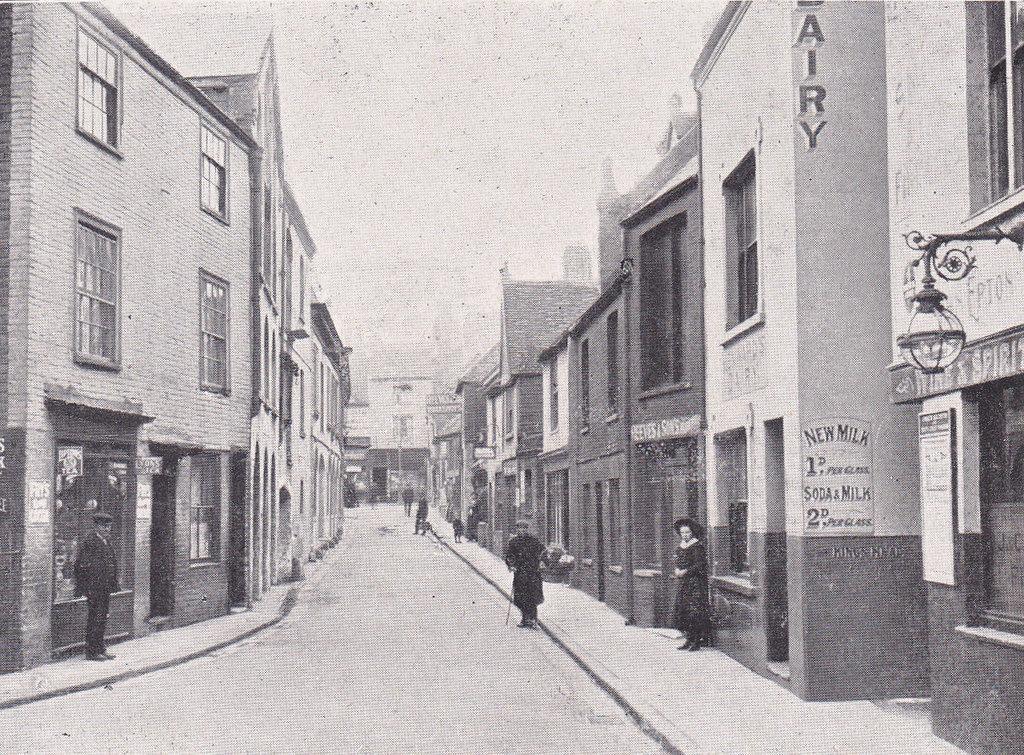How would you summarize this image in a sentence or two? In this image I can see a old photograph in which I can see the road, few buildings on both sides of the road, few persons standing on the road and few standing on the sidewalk, few windows of the building, a street light and in the background I can see the sky. 